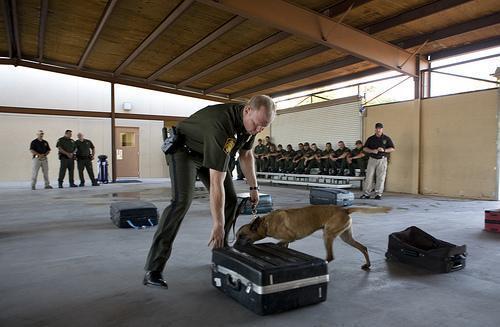How many dogs?
Give a very brief answer. 1. 